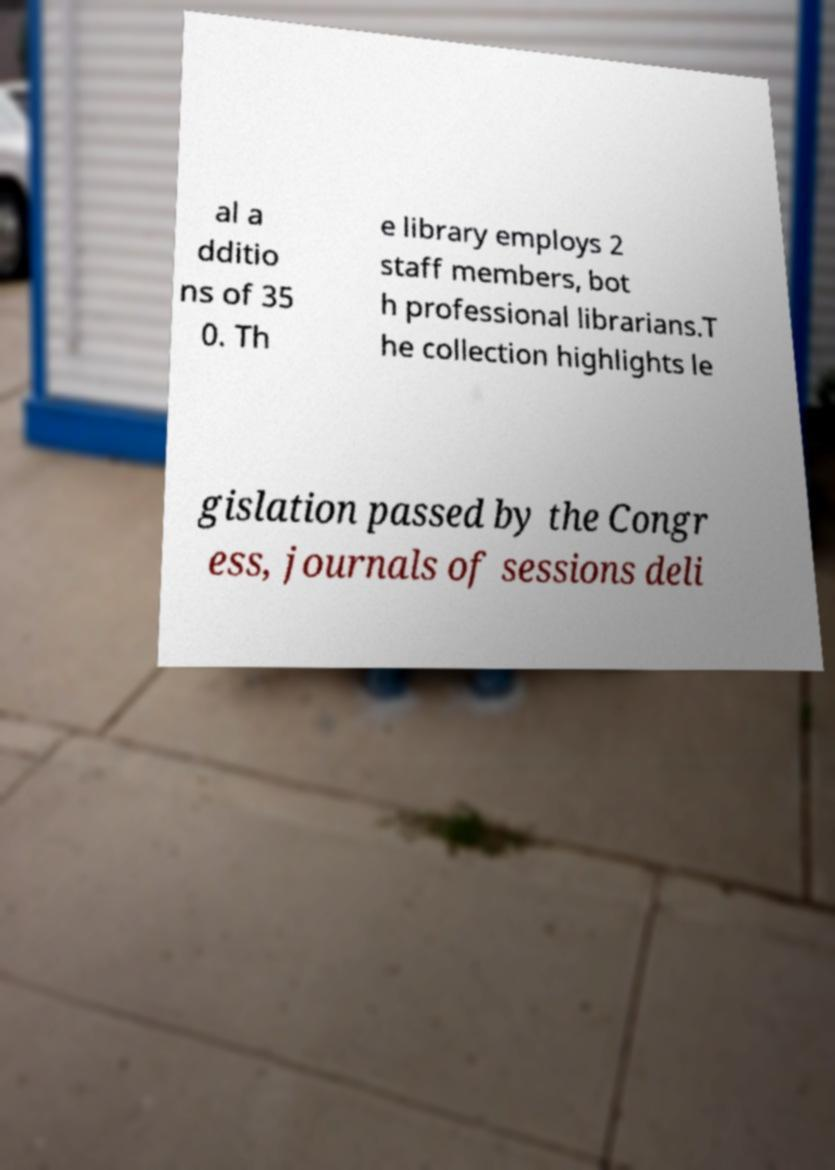Could you extract and type out the text from this image? al a dditio ns of 35 0. Th e library employs 2 staff members, bot h professional librarians.T he collection highlights le gislation passed by the Congr ess, journals of sessions deli 